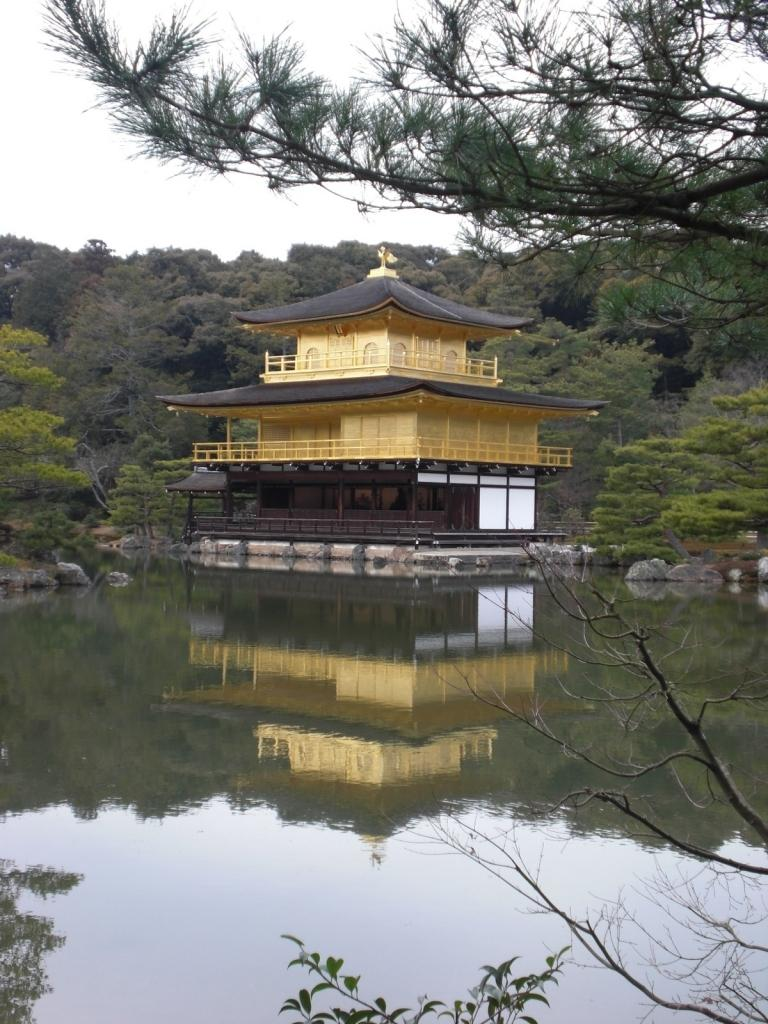What is in front of the image? There are leaves and dry branches in front of the image. What natural feature can be seen in the image? There is a river in the image. What is located on the other side of the river? There is a house and rocks on the other side of the river. What type of vegetation is visible on the other side of the river? Trees are visible on the other side of the river. What type of books can be found in the library depicted in the image? There is no library present in the image; it features a river, a house, rocks, and trees. 